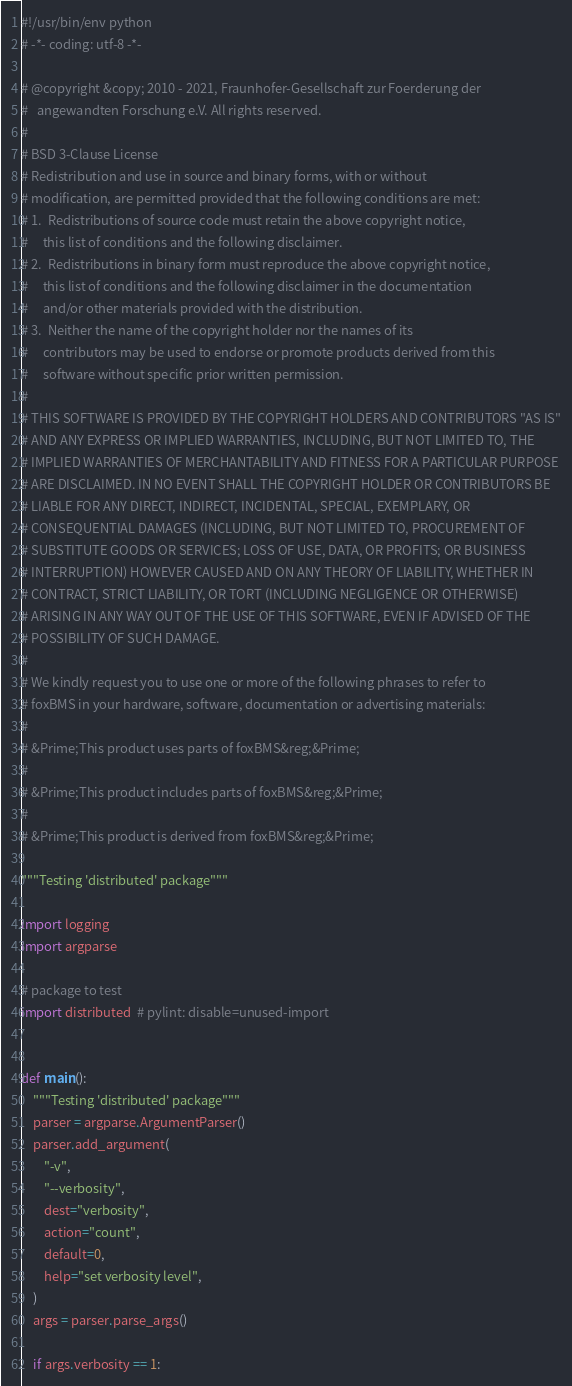<code> <loc_0><loc_0><loc_500><loc_500><_Python_>#!/usr/bin/env python
# -*- coding: utf-8 -*-

# @copyright &copy; 2010 - 2021, Fraunhofer-Gesellschaft zur Foerderung der
#   angewandten Forschung e.V. All rights reserved.
#
# BSD 3-Clause License
# Redistribution and use in source and binary forms, with or without
# modification, are permitted provided that the following conditions are met:
# 1.  Redistributions of source code must retain the above copyright notice,
#     this list of conditions and the following disclaimer.
# 2.  Redistributions in binary form must reproduce the above copyright notice,
#     this list of conditions and the following disclaimer in the documentation
#     and/or other materials provided with the distribution.
# 3.  Neither the name of the copyright holder nor the names of its
#     contributors may be used to endorse or promote products derived from this
#     software without specific prior written permission.
#
# THIS SOFTWARE IS PROVIDED BY THE COPYRIGHT HOLDERS AND CONTRIBUTORS "AS IS"
# AND ANY EXPRESS OR IMPLIED WARRANTIES, INCLUDING, BUT NOT LIMITED TO, THE
# IMPLIED WARRANTIES OF MERCHANTABILITY AND FITNESS FOR A PARTICULAR PURPOSE
# ARE DISCLAIMED. IN NO EVENT SHALL THE COPYRIGHT HOLDER OR CONTRIBUTORS BE
# LIABLE FOR ANY DIRECT, INDIRECT, INCIDENTAL, SPECIAL, EXEMPLARY, OR
# CONSEQUENTIAL DAMAGES (INCLUDING, BUT NOT LIMITED TO, PROCUREMENT OF
# SUBSTITUTE GOODS OR SERVICES; LOSS OF USE, DATA, OR PROFITS; OR BUSINESS
# INTERRUPTION) HOWEVER CAUSED AND ON ANY THEORY OF LIABILITY, WHETHER IN
# CONTRACT, STRICT LIABILITY, OR TORT (INCLUDING NEGLIGENCE OR OTHERWISE)
# ARISING IN ANY WAY OUT OF THE USE OF THIS SOFTWARE, EVEN IF ADVISED OF THE
# POSSIBILITY OF SUCH DAMAGE.
#
# We kindly request you to use one or more of the following phrases to refer to
# foxBMS in your hardware, software, documentation or advertising materials:
#
# &Prime;This product uses parts of foxBMS&reg;&Prime;
#
# &Prime;This product includes parts of foxBMS&reg;&Prime;
#
# &Prime;This product is derived from foxBMS&reg;&Prime;

"""Testing 'distributed' package"""

import logging
import argparse

# package to test
import distributed  # pylint: disable=unused-import


def main():
    """Testing 'distributed' package"""
    parser = argparse.ArgumentParser()
    parser.add_argument(
        "-v",
        "--verbosity",
        dest="verbosity",
        action="count",
        default=0,
        help="set verbosity level",
    )
    args = parser.parse_args()

    if args.verbosity == 1:</code> 